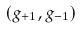<formula> <loc_0><loc_0><loc_500><loc_500>( g _ { + 1 } , g _ { - 1 } )</formula> 